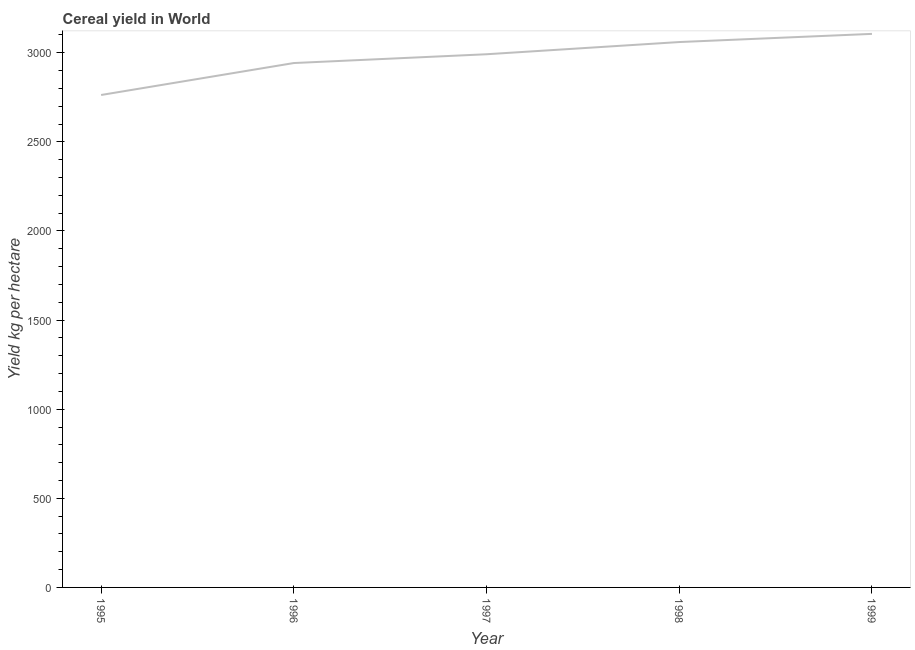What is the cereal yield in 1995?
Provide a succinct answer. 2762.85. Across all years, what is the maximum cereal yield?
Provide a short and direct response. 3105.69. Across all years, what is the minimum cereal yield?
Give a very brief answer. 2762.85. What is the sum of the cereal yield?
Your response must be concise. 1.49e+04. What is the difference between the cereal yield in 1998 and 1999?
Provide a succinct answer. -45.85. What is the average cereal yield per year?
Provide a short and direct response. 2972.37. What is the median cereal yield?
Keep it short and to the point. 2991.39. In how many years, is the cereal yield greater than 100 kg per hectare?
Your answer should be very brief. 5. Do a majority of the years between 1998 and 1997 (inclusive) have cereal yield greater than 1700 kg per hectare?
Your response must be concise. No. What is the ratio of the cereal yield in 1997 to that in 1999?
Your answer should be very brief. 0.96. What is the difference between the highest and the second highest cereal yield?
Make the answer very short. 45.85. Is the sum of the cereal yield in 1996 and 1999 greater than the maximum cereal yield across all years?
Give a very brief answer. Yes. What is the difference between the highest and the lowest cereal yield?
Your response must be concise. 342.84. What is the difference between two consecutive major ticks on the Y-axis?
Ensure brevity in your answer.  500. Does the graph contain any zero values?
Give a very brief answer. No. Does the graph contain grids?
Keep it short and to the point. No. What is the title of the graph?
Provide a short and direct response. Cereal yield in World. What is the label or title of the X-axis?
Your answer should be very brief. Year. What is the label or title of the Y-axis?
Your response must be concise. Yield kg per hectare. What is the Yield kg per hectare of 1995?
Your answer should be compact. 2762.85. What is the Yield kg per hectare in 1996?
Your answer should be very brief. 2942.09. What is the Yield kg per hectare in 1997?
Make the answer very short. 2991.39. What is the Yield kg per hectare of 1998?
Your answer should be very brief. 3059.84. What is the Yield kg per hectare in 1999?
Provide a short and direct response. 3105.69. What is the difference between the Yield kg per hectare in 1995 and 1996?
Keep it short and to the point. -179.25. What is the difference between the Yield kg per hectare in 1995 and 1997?
Ensure brevity in your answer.  -228.55. What is the difference between the Yield kg per hectare in 1995 and 1998?
Your response must be concise. -296.99. What is the difference between the Yield kg per hectare in 1995 and 1999?
Make the answer very short. -342.84. What is the difference between the Yield kg per hectare in 1996 and 1997?
Your response must be concise. -49.3. What is the difference between the Yield kg per hectare in 1996 and 1998?
Your response must be concise. -117.75. What is the difference between the Yield kg per hectare in 1996 and 1999?
Provide a succinct answer. -163.6. What is the difference between the Yield kg per hectare in 1997 and 1998?
Keep it short and to the point. -68.45. What is the difference between the Yield kg per hectare in 1997 and 1999?
Make the answer very short. -114.29. What is the difference between the Yield kg per hectare in 1998 and 1999?
Offer a very short reply. -45.85. What is the ratio of the Yield kg per hectare in 1995 to that in 1996?
Make the answer very short. 0.94. What is the ratio of the Yield kg per hectare in 1995 to that in 1997?
Your answer should be compact. 0.92. What is the ratio of the Yield kg per hectare in 1995 to that in 1998?
Give a very brief answer. 0.9. What is the ratio of the Yield kg per hectare in 1995 to that in 1999?
Provide a succinct answer. 0.89. What is the ratio of the Yield kg per hectare in 1996 to that in 1999?
Provide a short and direct response. 0.95. What is the ratio of the Yield kg per hectare in 1997 to that in 1998?
Keep it short and to the point. 0.98. What is the ratio of the Yield kg per hectare in 1998 to that in 1999?
Ensure brevity in your answer.  0.98. 